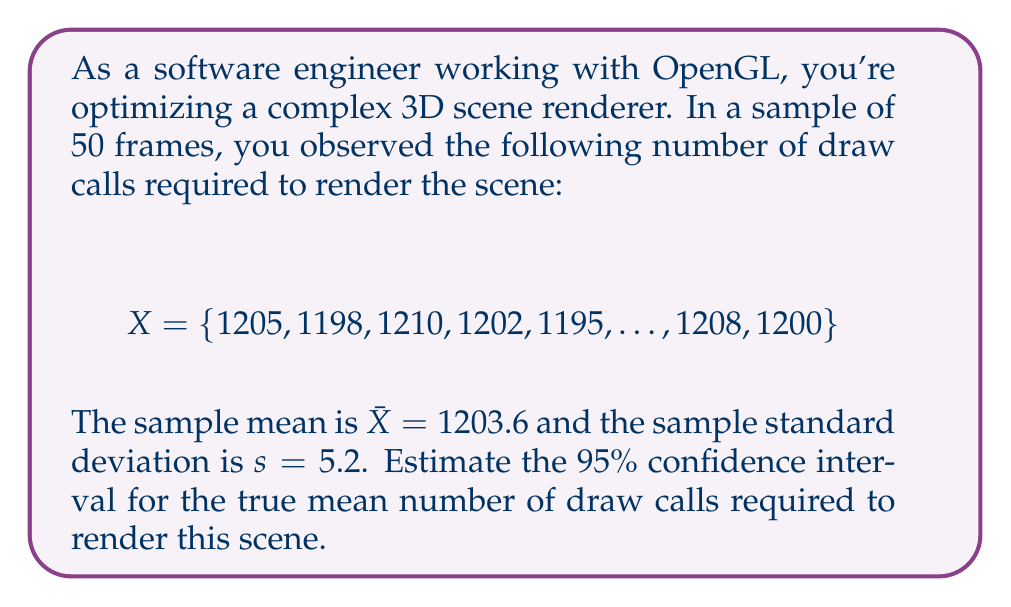Help me with this question. To estimate the confidence interval, we'll use the t-distribution since we have a small sample size (n < 30) and don't know the population standard deviation. Here are the steps:

1) We know:
   - Sample size: $n = 50$
   - Sample mean: $\bar{X} = 1203.6$
   - Sample standard deviation: $s = 5.2$
   - Confidence level: 95% (α = 0.05)

2) The formula for the confidence interval is:

   $$\bar{X} \pm t_{\frac{\alpha}{2}, n-1} \cdot \frac{s}{\sqrt{n}}$$

3) Find the critical t-value:
   - Degrees of freedom: $df = n - 1 = 49$
   - For a 95% confidence interval, $\frac{\alpha}{2} = 0.025$
   - From t-table or calculator: $t_{0.025, 49} \approx 2.010$

4) Calculate the margin of error:

   $$E = t_{\frac{\alpha}{2}, n-1} \cdot \frac{s}{\sqrt{n}} = 2.010 \cdot \frac{5.2}{\sqrt{50}} \approx 1.48$$

5) Calculate the confidence interval:

   $$1203.6 \pm 1.48$$

   Lower bound: $1203.6 - 1.48 = 1202.12$
   Upper bound: $1203.6 + 1.48 = 1205.08$

Therefore, we can be 95% confident that the true mean number of draw calls falls between 1202.12 and 1205.08.
Answer: (1202.12, 1205.08) 